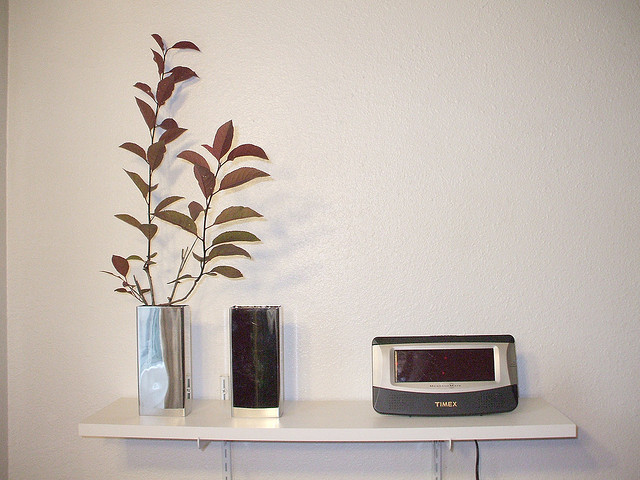Extract all visible text content from this image. TIMEX 